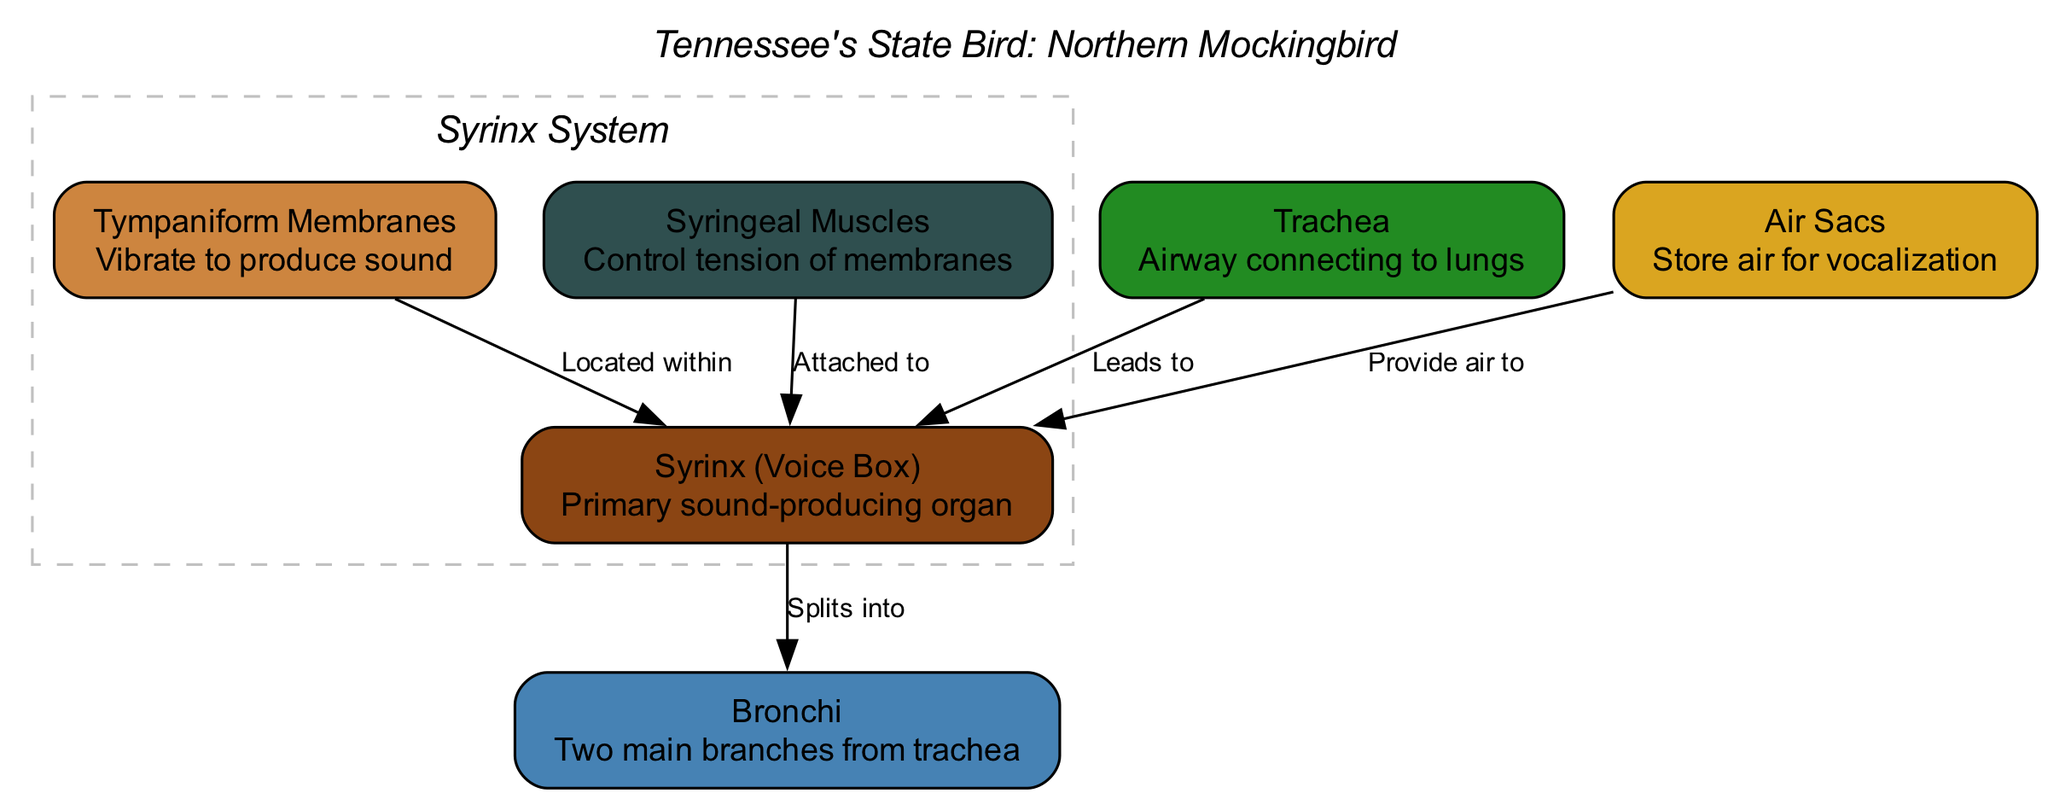What is the primary sound-producing organ of the Mockingbird? The diagram clearly labels the "Syrinx (Voice Box)" as the primary sound-producing organ. It's identified by the node labeled "syrinx" in the diagram, indicating its importance in vocalization.
Answer: Syrinx (Voice Box) How many main branches does the trachea split into? According to the diagram, the "Trachea" leads to the "Bronchi," which are indicated to be two main branches. This relationship is clearly shown by the directed edge from "trachea" to "bronchi."
Answer: Two Which organ provides air to the syrinx? The diagram explicitly states that "Air Sacs" are responsible for providing air to the "Syrinx." This is indicated by the directed edge from "airsacs" to "syrinx," demonstrating the flow of air necessary for vocalization.
Answer: Air Sacs What structure vibrates to produce sound in the syrinx? The "Tympaniform Membranes" are identified in the diagram as the structures that vibrate to produce sound. The relationship between these membranes and the syrinx is depicted through the edge showing that they are "Located within" the syrinx.
Answer: Tympaniform Membranes How are the syringeal muscles related to the syrinx? The diagram indicates that the "Syringeal Muscles" are "Attached to" the syrinx. This connection is vital for controlling the tension of the membranes that contribute to sound production, as shown in the directed edge from "muscles" to "syrinx."
Answer: Attached to In terms of Tennessee's cultural identity, what does the diagram suggest about the Mockingbird's vocal ability? The diagram contains an annotation stating that the "Unique vocal ability reflects TN's rich musical heritage." This highlights the significance of the Mockingbird's vocalization in connection with Tennessee's cultural identity and music.
Answer: Unique vocal ability reflects TN's rich musical heritage What anatomical structure does air travel through before reaching the syrinx? According to the diagram, air travels through the "Trachea," which is indicated as the airway connecting to the lungs before leading into the syrinx. This relationship is clearly demonstrated by the directed edge from "trachea" to "syrinx."
Answer: Trachea What anatomical component do the syrinx and tympaniform membranes share? Both the "Syrinx" and "Tympaniform Membranes" are related through the spatial relationship illustrated in the diagram, where the membranes are "Located within" the syrinx. This connectivity is crucial for sound production.
Answer: Located within 